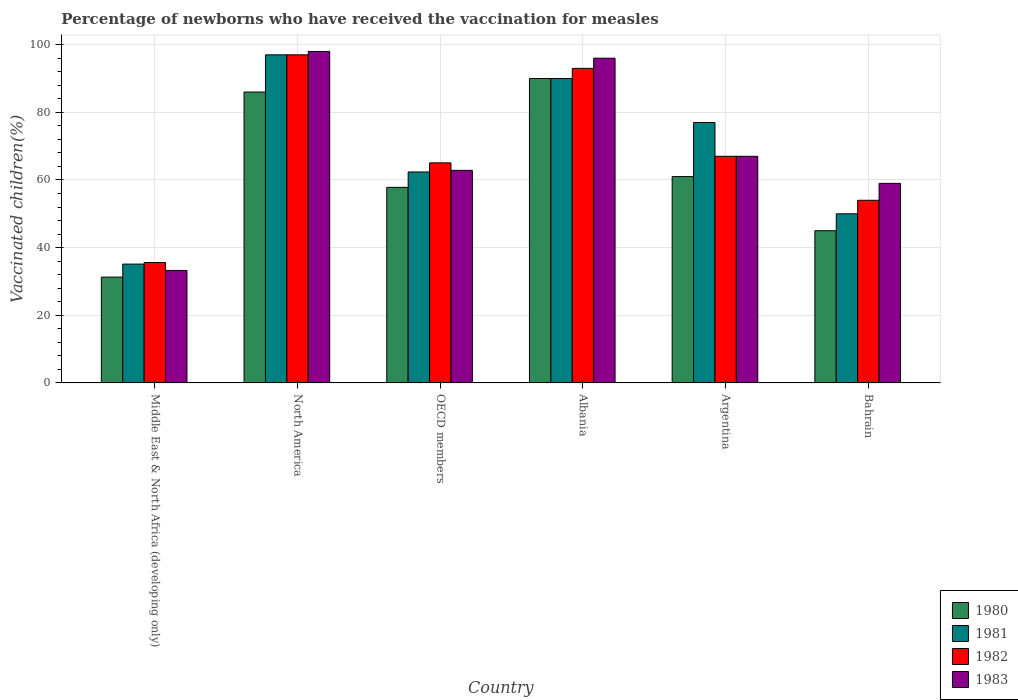How many groups of bars are there?
Your answer should be compact. 6. Are the number of bars per tick equal to the number of legend labels?
Give a very brief answer. Yes. Are the number of bars on each tick of the X-axis equal?
Your response must be concise. Yes. In how many cases, is the number of bars for a given country not equal to the number of legend labels?
Your answer should be very brief. 0. Across all countries, what is the minimum percentage of vaccinated children in 1983?
Offer a terse response. 33.26. In which country was the percentage of vaccinated children in 1980 maximum?
Provide a short and direct response. Albania. In which country was the percentage of vaccinated children in 1982 minimum?
Make the answer very short. Middle East & North Africa (developing only). What is the total percentage of vaccinated children in 1983 in the graph?
Your answer should be very brief. 416.1. What is the difference between the percentage of vaccinated children in 1982 in Argentina and that in Middle East & North Africa (developing only)?
Give a very brief answer. 31.4. What is the difference between the percentage of vaccinated children in 1983 in North America and the percentage of vaccinated children in 1982 in Argentina?
Your response must be concise. 31. What is the average percentage of vaccinated children in 1981 per country?
Your response must be concise. 68.58. In how many countries, is the percentage of vaccinated children in 1981 greater than 48 %?
Keep it short and to the point. 5. What is the ratio of the percentage of vaccinated children in 1980 in Bahrain to that in Middle East & North Africa (developing only)?
Offer a terse response. 1.44. What is the difference between the highest and the second highest percentage of vaccinated children in 1983?
Provide a short and direct response. -2. What is the difference between the highest and the lowest percentage of vaccinated children in 1981?
Your answer should be compact. 61.87. In how many countries, is the percentage of vaccinated children in 1983 greater than the average percentage of vaccinated children in 1983 taken over all countries?
Your answer should be compact. 2. Is it the case that in every country, the sum of the percentage of vaccinated children in 1981 and percentage of vaccinated children in 1983 is greater than the sum of percentage of vaccinated children in 1982 and percentage of vaccinated children in 1980?
Provide a short and direct response. No. What does the 3rd bar from the left in North America represents?
Give a very brief answer. 1982. Is it the case that in every country, the sum of the percentage of vaccinated children in 1981 and percentage of vaccinated children in 1980 is greater than the percentage of vaccinated children in 1982?
Offer a very short reply. Yes. How many bars are there?
Ensure brevity in your answer.  24. Are all the bars in the graph horizontal?
Provide a succinct answer. No. What is the difference between two consecutive major ticks on the Y-axis?
Your answer should be compact. 20. How many legend labels are there?
Provide a short and direct response. 4. How are the legend labels stacked?
Give a very brief answer. Vertical. What is the title of the graph?
Provide a short and direct response. Percentage of newborns who have received the vaccination for measles. Does "1960" appear as one of the legend labels in the graph?
Make the answer very short. No. What is the label or title of the Y-axis?
Your answer should be very brief. Vaccinated children(%). What is the Vaccinated children(%) of 1980 in Middle East & North Africa (developing only)?
Offer a terse response. 31.29. What is the Vaccinated children(%) in 1981 in Middle East & North Africa (developing only)?
Keep it short and to the point. 35.13. What is the Vaccinated children(%) in 1982 in Middle East & North Africa (developing only)?
Your answer should be very brief. 35.6. What is the Vaccinated children(%) of 1983 in Middle East & North Africa (developing only)?
Make the answer very short. 33.26. What is the Vaccinated children(%) of 1981 in North America?
Make the answer very short. 97. What is the Vaccinated children(%) in 1982 in North America?
Your answer should be compact. 97. What is the Vaccinated children(%) in 1980 in OECD members?
Your answer should be very brief. 57.82. What is the Vaccinated children(%) of 1981 in OECD members?
Ensure brevity in your answer.  62.37. What is the Vaccinated children(%) in 1982 in OECD members?
Offer a very short reply. 65.06. What is the Vaccinated children(%) in 1983 in OECD members?
Offer a terse response. 62.84. What is the Vaccinated children(%) in 1980 in Albania?
Your answer should be very brief. 90. What is the Vaccinated children(%) in 1981 in Albania?
Offer a very short reply. 90. What is the Vaccinated children(%) of 1982 in Albania?
Make the answer very short. 93. What is the Vaccinated children(%) of 1983 in Albania?
Your response must be concise. 96. What is the Vaccinated children(%) in 1981 in Argentina?
Your response must be concise. 77. What is the Vaccinated children(%) of 1982 in Argentina?
Ensure brevity in your answer.  67. What is the Vaccinated children(%) in 1980 in Bahrain?
Provide a succinct answer. 45. What is the Vaccinated children(%) of 1981 in Bahrain?
Your response must be concise. 50. What is the Vaccinated children(%) in 1983 in Bahrain?
Your answer should be compact. 59. Across all countries, what is the maximum Vaccinated children(%) in 1980?
Your response must be concise. 90. Across all countries, what is the maximum Vaccinated children(%) of 1981?
Provide a short and direct response. 97. Across all countries, what is the maximum Vaccinated children(%) of 1982?
Make the answer very short. 97. Across all countries, what is the maximum Vaccinated children(%) in 1983?
Your response must be concise. 98. Across all countries, what is the minimum Vaccinated children(%) in 1980?
Your response must be concise. 31.29. Across all countries, what is the minimum Vaccinated children(%) of 1981?
Make the answer very short. 35.13. Across all countries, what is the minimum Vaccinated children(%) in 1982?
Make the answer very short. 35.6. Across all countries, what is the minimum Vaccinated children(%) in 1983?
Your response must be concise. 33.26. What is the total Vaccinated children(%) in 1980 in the graph?
Keep it short and to the point. 371.11. What is the total Vaccinated children(%) in 1981 in the graph?
Keep it short and to the point. 411.51. What is the total Vaccinated children(%) of 1982 in the graph?
Provide a succinct answer. 411.66. What is the total Vaccinated children(%) of 1983 in the graph?
Your response must be concise. 416.1. What is the difference between the Vaccinated children(%) of 1980 in Middle East & North Africa (developing only) and that in North America?
Your answer should be compact. -54.71. What is the difference between the Vaccinated children(%) of 1981 in Middle East & North Africa (developing only) and that in North America?
Ensure brevity in your answer.  -61.87. What is the difference between the Vaccinated children(%) in 1982 in Middle East & North Africa (developing only) and that in North America?
Keep it short and to the point. -61.4. What is the difference between the Vaccinated children(%) in 1983 in Middle East & North Africa (developing only) and that in North America?
Give a very brief answer. -64.74. What is the difference between the Vaccinated children(%) in 1980 in Middle East & North Africa (developing only) and that in OECD members?
Your answer should be very brief. -26.53. What is the difference between the Vaccinated children(%) in 1981 in Middle East & North Africa (developing only) and that in OECD members?
Your answer should be very brief. -27.24. What is the difference between the Vaccinated children(%) of 1982 in Middle East & North Africa (developing only) and that in OECD members?
Give a very brief answer. -29.46. What is the difference between the Vaccinated children(%) of 1983 in Middle East & North Africa (developing only) and that in OECD members?
Your response must be concise. -29.59. What is the difference between the Vaccinated children(%) in 1980 in Middle East & North Africa (developing only) and that in Albania?
Make the answer very short. -58.71. What is the difference between the Vaccinated children(%) in 1981 in Middle East & North Africa (developing only) and that in Albania?
Offer a very short reply. -54.87. What is the difference between the Vaccinated children(%) of 1982 in Middle East & North Africa (developing only) and that in Albania?
Keep it short and to the point. -57.4. What is the difference between the Vaccinated children(%) of 1983 in Middle East & North Africa (developing only) and that in Albania?
Offer a terse response. -62.74. What is the difference between the Vaccinated children(%) of 1980 in Middle East & North Africa (developing only) and that in Argentina?
Your answer should be very brief. -29.71. What is the difference between the Vaccinated children(%) in 1981 in Middle East & North Africa (developing only) and that in Argentina?
Your response must be concise. -41.87. What is the difference between the Vaccinated children(%) in 1982 in Middle East & North Africa (developing only) and that in Argentina?
Provide a short and direct response. -31.4. What is the difference between the Vaccinated children(%) in 1983 in Middle East & North Africa (developing only) and that in Argentina?
Offer a very short reply. -33.74. What is the difference between the Vaccinated children(%) in 1980 in Middle East & North Africa (developing only) and that in Bahrain?
Ensure brevity in your answer.  -13.71. What is the difference between the Vaccinated children(%) of 1981 in Middle East & North Africa (developing only) and that in Bahrain?
Give a very brief answer. -14.87. What is the difference between the Vaccinated children(%) in 1982 in Middle East & North Africa (developing only) and that in Bahrain?
Offer a very short reply. -18.4. What is the difference between the Vaccinated children(%) in 1983 in Middle East & North Africa (developing only) and that in Bahrain?
Offer a very short reply. -25.74. What is the difference between the Vaccinated children(%) of 1980 in North America and that in OECD members?
Offer a very short reply. 28.18. What is the difference between the Vaccinated children(%) in 1981 in North America and that in OECD members?
Your answer should be compact. 34.63. What is the difference between the Vaccinated children(%) of 1982 in North America and that in OECD members?
Keep it short and to the point. 31.94. What is the difference between the Vaccinated children(%) in 1983 in North America and that in OECD members?
Offer a terse response. 35.16. What is the difference between the Vaccinated children(%) of 1980 in North America and that in Albania?
Provide a short and direct response. -4. What is the difference between the Vaccinated children(%) of 1980 in North America and that in Argentina?
Offer a terse response. 25. What is the difference between the Vaccinated children(%) of 1981 in North America and that in Argentina?
Provide a succinct answer. 20. What is the difference between the Vaccinated children(%) of 1981 in North America and that in Bahrain?
Keep it short and to the point. 47. What is the difference between the Vaccinated children(%) in 1982 in North America and that in Bahrain?
Your answer should be very brief. 43. What is the difference between the Vaccinated children(%) in 1980 in OECD members and that in Albania?
Provide a short and direct response. -32.18. What is the difference between the Vaccinated children(%) of 1981 in OECD members and that in Albania?
Keep it short and to the point. -27.63. What is the difference between the Vaccinated children(%) in 1982 in OECD members and that in Albania?
Offer a terse response. -27.94. What is the difference between the Vaccinated children(%) in 1983 in OECD members and that in Albania?
Make the answer very short. -33.16. What is the difference between the Vaccinated children(%) of 1980 in OECD members and that in Argentina?
Offer a terse response. -3.18. What is the difference between the Vaccinated children(%) of 1981 in OECD members and that in Argentina?
Your response must be concise. -14.63. What is the difference between the Vaccinated children(%) of 1982 in OECD members and that in Argentina?
Your answer should be compact. -1.94. What is the difference between the Vaccinated children(%) of 1983 in OECD members and that in Argentina?
Offer a very short reply. -4.16. What is the difference between the Vaccinated children(%) of 1980 in OECD members and that in Bahrain?
Provide a short and direct response. 12.82. What is the difference between the Vaccinated children(%) of 1981 in OECD members and that in Bahrain?
Provide a succinct answer. 12.37. What is the difference between the Vaccinated children(%) in 1982 in OECD members and that in Bahrain?
Your answer should be compact. 11.06. What is the difference between the Vaccinated children(%) of 1983 in OECD members and that in Bahrain?
Your response must be concise. 3.84. What is the difference between the Vaccinated children(%) in 1980 in Albania and that in Argentina?
Ensure brevity in your answer.  29. What is the difference between the Vaccinated children(%) in 1980 in Albania and that in Bahrain?
Ensure brevity in your answer.  45. What is the difference between the Vaccinated children(%) of 1981 in Albania and that in Bahrain?
Offer a very short reply. 40. What is the difference between the Vaccinated children(%) in 1980 in Argentina and that in Bahrain?
Your response must be concise. 16. What is the difference between the Vaccinated children(%) in 1980 in Middle East & North Africa (developing only) and the Vaccinated children(%) in 1981 in North America?
Ensure brevity in your answer.  -65.71. What is the difference between the Vaccinated children(%) of 1980 in Middle East & North Africa (developing only) and the Vaccinated children(%) of 1982 in North America?
Your answer should be compact. -65.71. What is the difference between the Vaccinated children(%) of 1980 in Middle East & North Africa (developing only) and the Vaccinated children(%) of 1983 in North America?
Give a very brief answer. -66.71. What is the difference between the Vaccinated children(%) of 1981 in Middle East & North Africa (developing only) and the Vaccinated children(%) of 1982 in North America?
Give a very brief answer. -61.87. What is the difference between the Vaccinated children(%) of 1981 in Middle East & North Africa (developing only) and the Vaccinated children(%) of 1983 in North America?
Your answer should be compact. -62.87. What is the difference between the Vaccinated children(%) in 1982 in Middle East & North Africa (developing only) and the Vaccinated children(%) in 1983 in North America?
Your answer should be very brief. -62.4. What is the difference between the Vaccinated children(%) of 1980 in Middle East & North Africa (developing only) and the Vaccinated children(%) of 1981 in OECD members?
Offer a very short reply. -31.08. What is the difference between the Vaccinated children(%) of 1980 in Middle East & North Africa (developing only) and the Vaccinated children(%) of 1982 in OECD members?
Make the answer very short. -33.77. What is the difference between the Vaccinated children(%) in 1980 in Middle East & North Africa (developing only) and the Vaccinated children(%) in 1983 in OECD members?
Provide a short and direct response. -31.55. What is the difference between the Vaccinated children(%) of 1981 in Middle East & North Africa (developing only) and the Vaccinated children(%) of 1982 in OECD members?
Ensure brevity in your answer.  -29.93. What is the difference between the Vaccinated children(%) in 1981 in Middle East & North Africa (developing only) and the Vaccinated children(%) in 1983 in OECD members?
Your answer should be very brief. -27.71. What is the difference between the Vaccinated children(%) of 1982 in Middle East & North Africa (developing only) and the Vaccinated children(%) of 1983 in OECD members?
Make the answer very short. -27.25. What is the difference between the Vaccinated children(%) of 1980 in Middle East & North Africa (developing only) and the Vaccinated children(%) of 1981 in Albania?
Your answer should be compact. -58.71. What is the difference between the Vaccinated children(%) in 1980 in Middle East & North Africa (developing only) and the Vaccinated children(%) in 1982 in Albania?
Ensure brevity in your answer.  -61.71. What is the difference between the Vaccinated children(%) of 1980 in Middle East & North Africa (developing only) and the Vaccinated children(%) of 1983 in Albania?
Your answer should be compact. -64.71. What is the difference between the Vaccinated children(%) of 1981 in Middle East & North Africa (developing only) and the Vaccinated children(%) of 1982 in Albania?
Your answer should be very brief. -57.87. What is the difference between the Vaccinated children(%) in 1981 in Middle East & North Africa (developing only) and the Vaccinated children(%) in 1983 in Albania?
Ensure brevity in your answer.  -60.87. What is the difference between the Vaccinated children(%) in 1982 in Middle East & North Africa (developing only) and the Vaccinated children(%) in 1983 in Albania?
Your answer should be very brief. -60.4. What is the difference between the Vaccinated children(%) of 1980 in Middle East & North Africa (developing only) and the Vaccinated children(%) of 1981 in Argentina?
Your response must be concise. -45.71. What is the difference between the Vaccinated children(%) in 1980 in Middle East & North Africa (developing only) and the Vaccinated children(%) in 1982 in Argentina?
Provide a short and direct response. -35.71. What is the difference between the Vaccinated children(%) in 1980 in Middle East & North Africa (developing only) and the Vaccinated children(%) in 1983 in Argentina?
Offer a terse response. -35.71. What is the difference between the Vaccinated children(%) of 1981 in Middle East & North Africa (developing only) and the Vaccinated children(%) of 1982 in Argentina?
Keep it short and to the point. -31.87. What is the difference between the Vaccinated children(%) of 1981 in Middle East & North Africa (developing only) and the Vaccinated children(%) of 1983 in Argentina?
Provide a short and direct response. -31.87. What is the difference between the Vaccinated children(%) of 1982 in Middle East & North Africa (developing only) and the Vaccinated children(%) of 1983 in Argentina?
Give a very brief answer. -31.4. What is the difference between the Vaccinated children(%) in 1980 in Middle East & North Africa (developing only) and the Vaccinated children(%) in 1981 in Bahrain?
Ensure brevity in your answer.  -18.71. What is the difference between the Vaccinated children(%) of 1980 in Middle East & North Africa (developing only) and the Vaccinated children(%) of 1982 in Bahrain?
Offer a very short reply. -22.71. What is the difference between the Vaccinated children(%) of 1980 in Middle East & North Africa (developing only) and the Vaccinated children(%) of 1983 in Bahrain?
Provide a succinct answer. -27.71. What is the difference between the Vaccinated children(%) of 1981 in Middle East & North Africa (developing only) and the Vaccinated children(%) of 1982 in Bahrain?
Give a very brief answer. -18.87. What is the difference between the Vaccinated children(%) in 1981 in Middle East & North Africa (developing only) and the Vaccinated children(%) in 1983 in Bahrain?
Provide a short and direct response. -23.87. What is the difference between the Vaccinated children(%) of 1982 in Middle East & North Africa (developing only) and the Vaccinated children(%) of 1983 in Bahrain?
Keep it short and to the point. -23.4. What is the difference between the Vaccinated children(%) in 1980 in North America and the Vaccinated children(%) in 1981 in OECD members?
Provide a succinct answer. 23.63. What is the difference between the Vaccinated children(%) of 1980 in North America and the Vaccinated children(%) of 1982 in OECD members?
Make the answer very short. 20.94. What is the difference between the Vaccinated children(%) of 1980 in North America and the Vaccinated children(%) of 1983 in OECD members?
Provide a short and direct response. 23.16. What is the difference between the Vaccinated children(%) of 1981 in North America and the Vaccinated children(%) of 1982 in OECD members?
Provide a succinct answer. 31.94. What is the difference between the Vaccinated children(%) of 1981 in North America and the Vaccinated children(%) of 1983 in OECD members?
Make the answer very short. 34.16. What is the difference between the Vaccinated children(%) in 1982 in North America and the Vaccinated children(%) in 1983 in OECD members?
Offer a very short reply. 34.16. What is the difference between the Vaccinated children(%) of 1980 in North America and the Vaccinated children(%) of 1982 in Albania?
Give a very brief answer. -7. What is the difference between the Vaccinated children(%) in 1980 in North America and the Vaccinated children(%) in 1983 in Albania?
Make the answer very short. -10. What is the difference between the Vaccinated children(%) in 1981 in North America and the Vaccinated children(%) in 1982 in Albania?
Make the answer very short. 4. What is the difference between the Vaccinated children(%) of 1981 in North America and the Vaccinated children(%) of 1983 in Albania?
Your answer should be very brief. 1. What is the difference between the Vaccinated children(%) of 1980 in North America and the Vaccinated children(%) of 1982 in Argentina?
Make the answer very short. 19. What is the difference between the Vaccinated children(%) of 1980 in North America and the Vaccinated children(%) of 1983 in Argentina?
Your response must be concise. 19. What is the difference between the Vaccinated children(%) in 1980 in North America and the Vaccinated children(%) in 1981 in Bahrain?
Offer a very short reply. 36. What is the difference between the Vaccinated children(%) of 1980 in North America and the Vaccinated children(%) of 1983 in Bahrain?
Your answer should be compact. 27. What is the difference between the Vaccinated children(%) in 1981 in North America and the Vaccinated children(%) in 1982 in Bahrain?
Make the answer very short. 43. What is the difference between the Vaccinated children(%) in 1981 in North America and the Vaccinated children(%) in 1983 in Bahrain?
Provide a short and direct response. 38. What is the difference between the Vaccinated children(%) in 1982 in North America and the Vaccinated children(%) in 1983 in Bahrain?
Give a very brief answer. 38. What is the difference between the Vaccinated children(%) in 1980 in OECD members and the Vaccinated children(%) in 1981 in Albania?
Your answer should be very brief. -32.18. What is the difference between the Vaccinated children(%) of 1980 in OECD members and the Vaccinated children(%) of 1982 in Albania?
Make the answer very short. -35.18. What is the difference between the Vaccinated children(%) of 1980 in OECD members and the Vaccinated children(%) of 1983 in Albania?
Your answer should be very brief. -38.18. What is the difference between the Vaccinated children(%) in 1981 in OECD members and the Vaccinated children(%) in 1982 in Albania?
Keep it short and to the point. -30.63. What is the difference between the Vaccinated children(%) in 1981 in OECD members and the Vaccinated children(%) in 1983 in Albania?
Your answer should be very brief. -33.63. What is the difference between the Vaccinated children(%) in 1982 in OECD members and the Vaccinated children(%) in 1983 in Albania?
Keep it short and to the point. -30.94. What is the difference between the Vaccinated children(%) in 1980 in OECD members and the Vaccinated children(%) in 1981 in Argentina?
Make the answer very short. -19.18. What is the difference between the Vaccinated children(%) in 1980 in OECD members and the Vaccinated children(%) in 1982 in Argentina?
Provide a short and direct response. -9.18. What is the difference between the Vaccinated children(%) in 1980 in OECD members and the Vaccinated children(%) in 1983 in Argentina?
Keep it short and to the point. -9.18. What is the difference between the Vaccinated children(%) in 1981 in OECD members and the Vaccinated children(%) in 1982 in Argentina?
Your answer should be very brief. -4.63. What is the difference between the Vaccinated children(%) in 1981 in OECD members and the Vaccinated children(%) in 1983 in Argentina?
Provide a succinct answer. -4.63. What is the difference between the Vaccinated children(%) in 1982 in OECD members and the Vaccinated children(%) in 1983 in Argentina?
Your answer should be compact. -1.94. What is the difference between the Vaccinated children(%) in 1980 in OECD members and the Vaccinated children(%) in 1981 in Bahrain?
Offer a very short reply. 7.82. What is the difference between the Vaccinated children(%) in 1980 in OECD members and the Vaccinated children(%) in 1982 in Bahrain?
Give a very brief answer. 3.82. What is the difference between the Vaccinated children(%) in 1980 in OECD members and the Vaccinated children(%) in 1983 in Bahrain?
Offer a terse response. -1.18. What is the difference between the Vaccinated children(%) in 1981 in OECD members and the Vaccinated children(%) in 1982 in Bahrain?
Make the answer very short. 8.37. What is the difference between the Vaccinated children(%) of 1981 in OECD members and the Vaccinated children(%) of 1983 in Bahrain?
Give a very brief answer. 3.37. What is the difference between the Vaccinated children(%) in 1982 in OECD members and the Vaccinated children(%) in 1983 in Bahrain?
Offer a very short reply. 6.06. What is the difference between the Vaccinated children(%) of 1980 in Albania and the Vaccinated children(%) of 1981 in Argentina?
Your response must be concise. 13. What is the difference between the Vaccinated children(%) in 1981 in Albania and the Vaccinated children(%) in 1983 in Bahrain?
Provide a short and direct response. 31. What is the difference between the Vaccinated children(%) of 1982 in Albania and the Vaccinated children(%) of 1983 in Bahrain?
Your answer should be very brief. 34. What is the difference between the Vaccinated children(%) in 1980 in Argentina and the Vaccinated children(%) in 1981 in Bahrain?
Make the answer very short. 11. What is the difference between the Vaccinated children(%) of 1980 in Argentina and the Vaccinated children(%) of 1982 in Bahrain?
Offer a terse response. 7. What is the difference between the Vaccinated children(%) in 1981 in Argentina and the Vaccinated children(%) in 1982 in Bahrain?
Your answer should be very brief. 23. What is the difference between the Vaccinated children(%) of 1981 in Argentina and the Vaccinated children(%) of 1983 in Bahrain?
Offer a terse response. 18. What is the average Vaccinated children(%) of 1980 per country?
Ensure brevity in your answer.  61.85. What is the average Vaccinated children(%) of 1981 per country?
Keep it short and to the point. 68.58. What is the average Vaccinated children(%) in 1982 per country?
Keep it short and to the point. 68.61. What is the average Vaccinated children(%) in 1983 per country?
Offer a very short reply. 69.35. What is the difference between the Vaccinated children(%) of 1980 and Vaccinated children(%) of 1981 in Middle East & North Africa (developing only)?
Your answer should be compact. -3.84. What is the difference between the Vaccinated children(%) in 1980 and Vaccinated children(%) in 1982 in Middle East & North Africa (developing only)?
Give a very brief answer. -4.31. What is the difference between the Vaccinated children(%) in 1980 and Vaccinated children(%) in 1983 in Middle East & North Africa (developing only)?
Your answer should be very brief. -1.97. What is the difference between the Vaccinated children(%) of 1981 and Vaccinated children(%) of 1982 in Middle East & North Africa (developing only)?
Provide a succinct answer. -0.46. What is the difference between the Vaccinated children(%) of 1981 and Vaccinated children(%) of 1983 in Middle East & North Africa (developing only)?
Your answer should be very brief. 1.88. What is the difference between the Vaccinated children(%) in 1982 and Vaccinated children(%) in 1983 in Middle East & North Africa (developing only)?
Offer a very short reply. 2.34. What is the difference between the Vaccinated children(%) of 1980 and Vaccinated children(%) of 1982 in North America?
Offer a very short reply. -11. What is the difference between the Vaccinated children(%) in 1980 and Vaccinated children(%) in 1983 in North America?
Keep it short and to the point. -12. What is the difference between the Vaccinated children(%) of 1980 and Vaccinated children(%) of 1981 in OECD members?
Provide a short and direct response. -4.55. What is the difference between the Vaccinated children(%) of 1980 and Vaccinated children(%) of 1982 in OECD members?
Provide a short and direct response. -7.24. What is the difference between the Vaccinated children(%) of 1980 and Vaccinated children(%) of 1983 in OECD members?
Your answer should be very brief. -5.02. What is the difference between the Vaccinated children(%) in 1981 and Vaccinated children(%) in 1982 in OECD members?
Provide a succinct answer. -2.69. What is the difference between the Vaccinated children(%) in 1981 and Vaccinated children(%) in 1983 in OECD members?
Ensure brevity in your answer.  -0.47. What is the difference between the Vaccinated children(%) of 1982 and Vaccinated children(%) of 1983 in OECD members?
Offer a very short reply. 2.22. What is the difference between the Vaccinated children(%) in 1980 and Vaccinated children(%) in 1983 in Albania?
Offer a terse response. -6. What is the difference between the Vaccinated children(%) in 1981 and Vaccinated children(%) in 1983 in Albania?
Ensure brevity in your answer.  -6. What is the difference between the Vaccinated children(%) in 1982 and Vaccinated children(%) in 1983 in Albania?
Offer a terse response. -3. What is the difference between the Vaccinated children(%) of 1980 and Vaccinated children(%) of 1982 in Argentina?
Provide a short and direct response. -6. What is the difference between the Vaccinated children(%) in 1981 and Vaccinated children(%) in 1982 in Argentina?
Offer a very short reply. 10. What is the difference between the Vaccinated children(%) of 1981 and Vaccinated children(%) of 1983 in Argentina?
Offer a very short reply. 10. What is the difference between the Vaccinated children(%) in 1982 and Vaccinated children(%) in 1983 in Argentina?
Keep it short and to the point. 0. What is the difference between the Vaccinated children(%) of 1980 and Vaccinated children(%) of 1981 in Bahrain?
Provide a short and direct response. -5. What is the difference between the Vaccinated children(%) in 1980 and Vaccinated children(%) in 1982 in Bahrain?
Your response must be concise. -9. What is the difference between the Vaccinated children(%) in 1980 and Vaccinated children(%) in 1983 in Bahrain?
Make the answer very short. -14. What is the difference between the Vaccinated children(%) in 1981 and Vaccinated children(%) in 1982 in Bahrain?
Give a very brief answer. -4. What is the difference between the Vaccinated children(%) of 1981 and Vaccinated children(%) of 1983 in Bahrain?
Your answer should be very brief. -9. What is the difference between the Vaccinated children(%) in 1982 and Vaccinated children(%) in 1983 in Bahrain?
Give a very brief answer. -5. What is the ratio of the Vaccinated children(%) of 1980 in Middle East & North Africa (developing only) to that in North America?
Your answer should be very brief. 0.36. What is the ratio of the Vaccinated children(%) in 1981 in Middle East & North Africa (developing only) to that in North America?
Make the answer very short. 0.36. What is the ratio of the Vaccinated children(%) in 1982 in Middle East & North Africa (developing only) to that in North America?
Your response must be concise. 0.37. What is the ratio of the Vaccinated children(%) in 1983 in Middle East & North Africa (developing only) to that in North America?
Give a very brief answer. 0.34. What is the ratio of the Vaccinated children(%) in 1980 in Middle East & North Africa (developing only) to that in OECD members?
Make the answer very short. 0.54. What is the ratio of the Vaccinated children(%) in 1981 in Middle East & North Africa (developing only) to that in OECD members?
Ensure brevity in your answer.  0.56. What is the ratio of the Vaccinated children(%) of 1982 in Middle East & North Africa (developing only) to that in OECD members?
Your answer should be very brief. 0.55. What is the ratio of the Vaccinated children(%) of 1983 in Middle East & North Africa (developing only) to that in OECD members?
Your answer should be compact. 0.53. What is the ratio of the Vaccinated children(%) of 1980 in Middle East & North Africa (developing only) to that in Albania?
Give a very brief answer. 0.35. What is the ratio of the Vaccinated children(%) of 1981 in Middle East & North Africa (developing only) to that in Albania?
Your response must be concise. 0.39. What is the ratio of the Vaccinated children(%) of 1982 in Middle East & North Africa (developing only) to that in Albania?
Make the answer very short. 0.38. What is the ratio of the Vaccinated children(%) of 1983 in Middle East & North Africa (developing only) to that in Albania?
Offer a very short reply. 0.35. What is the ratio of the Vaccinated children(%) of 1980 in Middle East & North Africa (developing only) to that in Argentina?
Ensure brevity in your answer.  0.51. What is the ratio of the Vaccinated children(%) in 1981 in Middle East & North Africa (developing only) to that in Argentina?
Make the answer very short. 0.46. What is the ratio of the Vaccinated children(%) of 1982 in Middle East & North Africa (developing only) to that in Argentina?
Give a very brief answer. 0.53. What is the ratio of the Vaccinated children(%) of 1983 in Middle East & North Africa (developing only) to that in Argentina?
Provide a succinct answer. 0.5. What is the ratio of the Vaccinated children(%) of 1980 in Middle East & North Africa (developing only) to that in Bahrain?
Your answer should be very brief. 0.7. What is the ratio of the Vaccinated children(%) of 1981 in Middle East & North Africa (developing only) to that in Bahrain?
Your response must be concise. 0.7. What is the ratio of the Vaccinated children(%) in 1982 in Middle East & North Africa (developing only) to that in Bahrain?
Give a very brief answer. 0.66. What is the ratio of the Vaccinated children(%) of 1983 in Middle East & North Africa (developing only) to that in Bahrain?
Your answer should be compact. 0.56. What is the ratio of the Vaccinated children(%) of 1980 in North America to that in OECD members?
Your answer should be compact. 1.49. What is the ratio of the Vaccinated children(%) of 1981 in North America to that in OECD members?
Provide a short and direct response. 1.56. What is the ratio of the Vaccinated children(%) of 1982 in North America to that in OECD members?
Your answer should be very brief. 1.49. What is the ratio of the Vaccinated children(%) of 1983 in North America to that in OECD members?
Offer a very short reply. 1.56. What is the ratio of the Vaccinated children(%) of 1980 in North America to that in Albania?
Provide a succinct answer. 0.96. What is the ratio of the Vaccinated children(%) in 1981 in North America to that in Albania?
Provide a short and direct response. 1.08. What is the ratio of the Vaccinated children(%) in 1982 in North America to that in Albania?
Your answer should be compact. 1.04. What is the ratio of the Vaccinated children(%) of 1983 in North America to that in Albania?
Offer a very short reply. 1.02. What is the ratio of the Vaccinated children(%) of 1980 in North America to that in Argentina?
Make the answer very short. 1.41. What is the ratio of the Vaccinated children(%) in 1981 in North America to that in Argentina?
Keep it short and to the point. 1.26. What is the ratio of the Vaccinated children(%) of 1982 in North America to that in Argentina?
Make the answer very short. 1.45. What is the ratio of the Vaccinated children(%) in 1983 in North America to that in Argentina?
Offer a terse response. 1.46. What is the ratio of the Vaccinated children(%) in 1980 in North America to that in Bahrain?
Your answer should be very brief. 1.91. What is the ratio of the Vaccinated children(%) in 1981 in North America to that in Bahrain?
Make the answer very short. 1.94. What is the ratio of the Vaccinated children(%) of 1982 in North America to that in Bahrain?
Make the answer very short. 1.8. What is the ratio of the Vaccinated children(%) of 1983 in North America to that in Bahrain?
Provide a short and direct response. 1.66. What is the ratio of the Vaccinated children(%) in 1980 in OECD members to that in Albania?
Keep it short and to the point. 0.64. What is the ratio of the Vaccinated children(%) of 1981 in OECD members to that in Albania?
Offer a very short reply. 0.69. What is the ratio of the Vaccinated children(%) in 1982 in OECD members to that in Albania?
Offer a terse response. 0.7. What is the ratio of the Vaccinated children(%) in 1983 in OECD members to that in Albania?
Make the answer very short. 0.65. What is the ratio of the Vaccinated children(%) of 1980 in OECD members to that in Argentina?
Offer a terse response. 0.95. What is the ratio of the Vaccinated children(%) of 1981 in OECD members to that in Argentina?
Your response must be concise. 0.81. What is the ratio of the Vaccinated children(%) in 1982 in OECD members to that in Argentina?
Make the answer very short. 0.97. What is the ratio of the Vaccinated children(%) in 1983 in OECD members to that in Argentina?
Your answer should be very brief. 0.94. What is the ratio of the Vaccinated children(%) of 1980 in OECD members to that in Bahrain?
Make the answer very short. 1.28. What is the ratio of the Vaccinated children(%) in 1981 in OECD members to that in Bahrain?
Your response must be concise. 1.25. What is the ratio of the Vaccinated children(%) of 1982 in OECD members to that in Bahrain?
Your response must be concise. 1.2. What is the ratio of the Vaccinated children(%) in 1983 in OECD members to that in Bahrain?
Make the answer very short. 1.07. What is the ratio of the Vaccinated children(%) of 1980 in Albania to that in Argentina?
Provide a short and direct response. 1.48. What is the ratio of the Vaccinated children(%) of 1981 in Albania to that in Argentina?
Provide a short and direct response. 1.17. What is the ratio of the Vaccinated children(%) of 1982 in Albania to that in Argentina?
Your response must be concise. 1.39. What is the ratio of the Vaccinated children(%) of 1983 in Albania to that in Argentina?
Give a very brief answer. 1.43. What is the ratio of the Vaccinated children(%) in 1980 in Albania to that in Bahrain?
Your answer should be very brief. 2. What is the ratio of the Vaccinated children(%) in 1982 in Albania to that in Bahrain?
Make the answer very short. 1.72. What is the ratio of the Vaccinated children(%) of 1983 in Albania to that in Bahrain?
Your response must be concise. 1.63. What is the ratio of the Vaccinated children(%) of 1980 in Argentina to that in Bahrain?
Your response must be concise. 1.36. What is the ratio of the Vaccinated children(%) of 1981 in Argentina to that in Bahrain?
Provide a succinct answer. 1.54. What is the ratio of the Vaccinated children(%) in 1982 in Argentina to that in Bahrain?
Offer a terse response. 1.24. What is the ratio of the Vaccinated children(%) in 1983 in Argentina to that in Bahrain?
Your response must be concise. 1.14. What is the difference between the highest and the second highest Vaccinated children(%) of 1982?
Keep it short and to the point. 4. What is the difference between the highest and the lowest Vaccinated children(%) of 1980?
Keep it short and to the point. 58.71. What is the difference between the highest and the lowest Vaccinated children(%) in 1981?
Give a very brief answer. 61.87. What is the difference between the highest and the lowest Vaccinated children(%) in 1982?
Provide a short and direct response. 61.4. What is the difference between the highest and the lowest Vaccinated children(%) of 1983?
Ensure brevity in your answer.  64.74. 